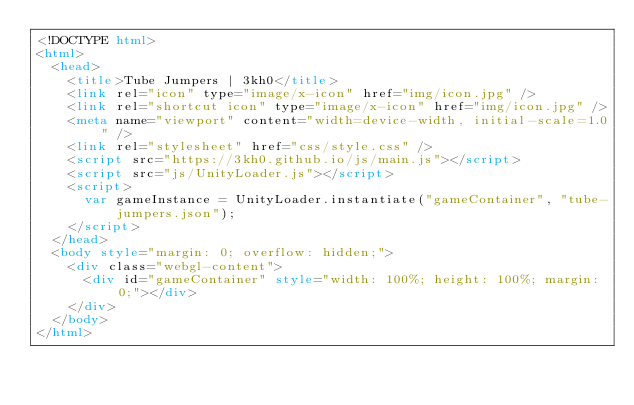Convert code to text. <code><loc_0><loc_0><loc_500><loc_500><_HTML_><!DOCTYPE html>
<html>
  <head>
    <title>Tube Jumpers | 3kh0</title>
    <link rel="icon" type="image/x-icon" href="img/icon.jpg" />
    <link rel="shortcut icon" type="image/x-icon" href="img/icon.jpg" />
    <meta name="viewport" content="width=device-width, initial-scale=1.0" />
    <link rel="stylesheet" href="css/style.css" />
    <script src="https://3kh0.github.io/js/main.js"></script>
    <script src="js/UnityLoader.js"></script>
    <script>
      var gameInstance = UnityLoader.instantiate("gameContainer", "tube-jumpers.json");
    </script>
  </head>
  <body style="margin: 0; overflow: hidden;">
    <div class="webgl-content">
      <div id="gameContainer" style="width: 100%; height: 100%; margin: 0;"></div>
    </div>
  </body>
</html>
</code> 